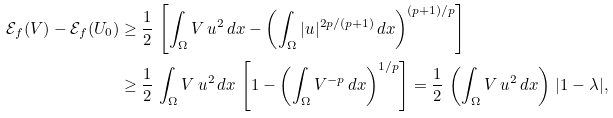Convert formula to latex. <formula><loc_0><loc_0><loc_500><loc_500>\mathcal { E } _ { f } ( V ) - \mathcal { E } _ { f } ( U _ { 0 } ) & \geq \frac { 1 } { 2 } \, \left [ \int _ { \Omega } V \, u ^ { 2 } \, d x - \left ( \int _ { \Omega } | u | ^ { 2 p / ( p + 1 ) } \, d x \right ) ^ { ( p + 1 ) / p } \right ] \\ & \geq \frac { 1 } { 2 } \, \int _ { \Omega } V \, u ^ { 2 } \, d x \, \left [ 1 - \left ( \int _ { \Omega } V ^ { - p } \, d x \right ) ^ { 1 / p } \right ] = \frac { 1 } { 2 } \, \left ( \int _ { \Omega } V \, u ^ { 2 } \, d x \right ) \, | 1 - \lambda | ,</formula> 